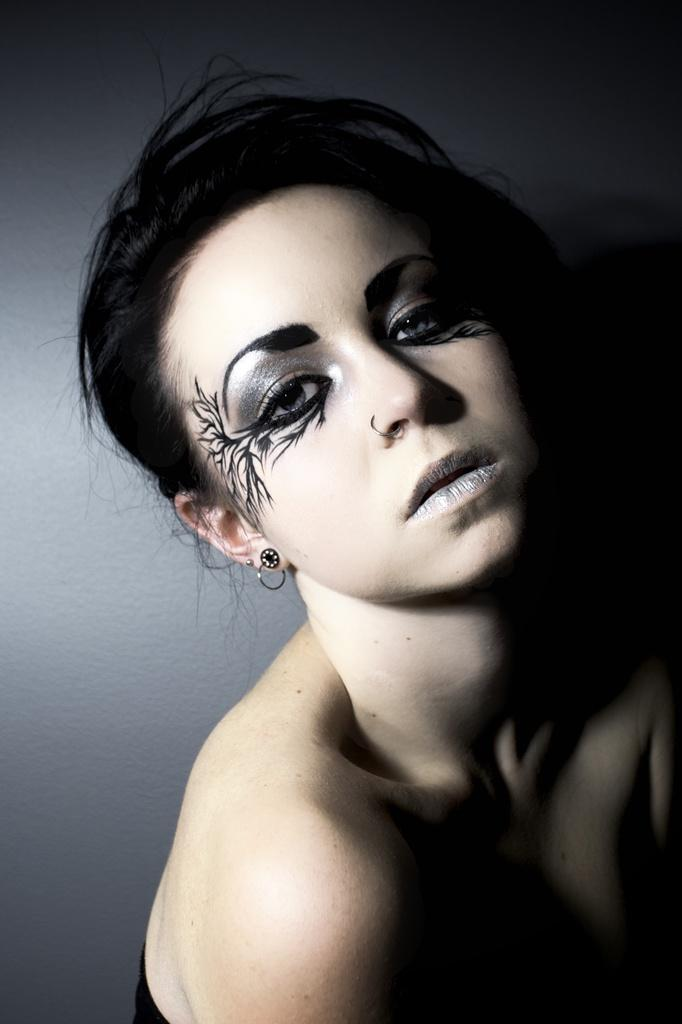Who is present in the image? There is a woman in the image. How many men are visible in the image? There are no men visible in the image; only a woman is present. What type of tray is being used by the woman in the image? There is no tray present in the image; the woman is the only subject visible. 